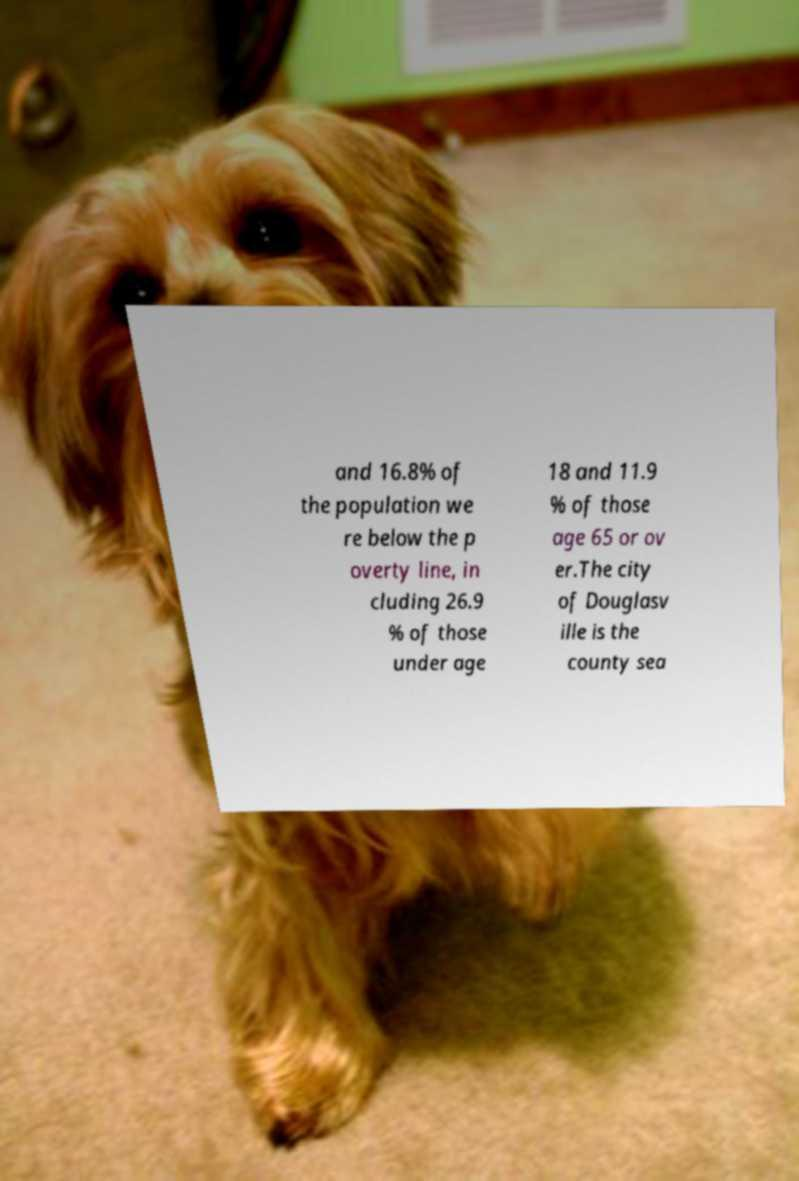Please read and relay the text visible in this image. What does it say? and 16.8% of the population we re below the p overty line, in cluding 26.9 % of those under age 18 and 11.9 % of those age 65 or ov er.The city of Douglasv ille is the county sea 